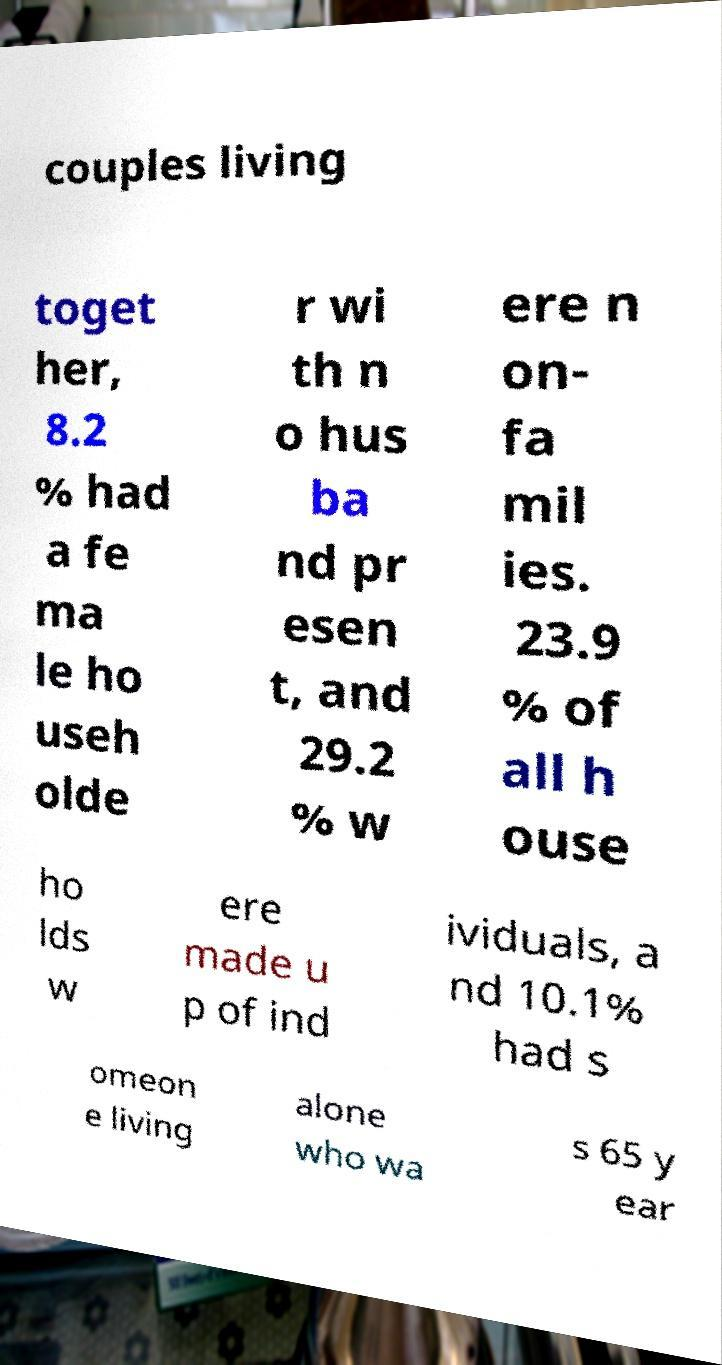Can you read and provide the text displayed in the image?This photo seems to have some interesting text. Can you extract and type it out for me? couples living toget her, 8.2 % had a fe ma le ho useh olde r wi th n o hus ba nd pr esen t, and 29.2 % w ere n on- fa mil ies. 23.9 % of all h ouse ho lds w ere made u p of ind ividuals, a nd 10.1% had s omeon e living alone who wa s 65 y ear 